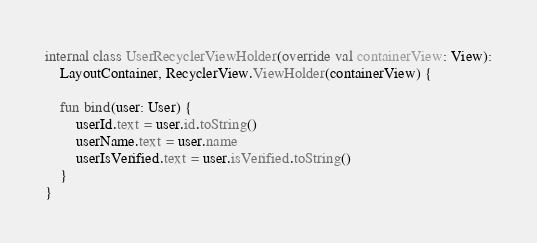Convert code to text. <code><loc_0><loc_0><loc_500><loc_500><_Kotlin_>
internal class UserRecyclerViewHolder(override val containerView: View):
    LayoutContainer, RecyclerView.ViewHolder(containerView) {

    fun bind(user: User) {
        userId.text = user.id.toString()
        userName.text = user.name
        userIsVerified.text = user.isVerified.toString()
    }
}
</code> 